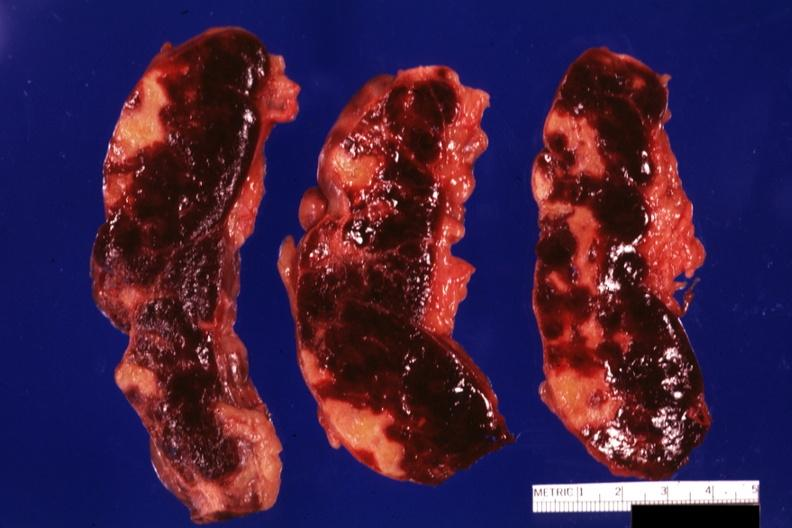s spleen present?
Answer the question using a single word or phrase. Yes 